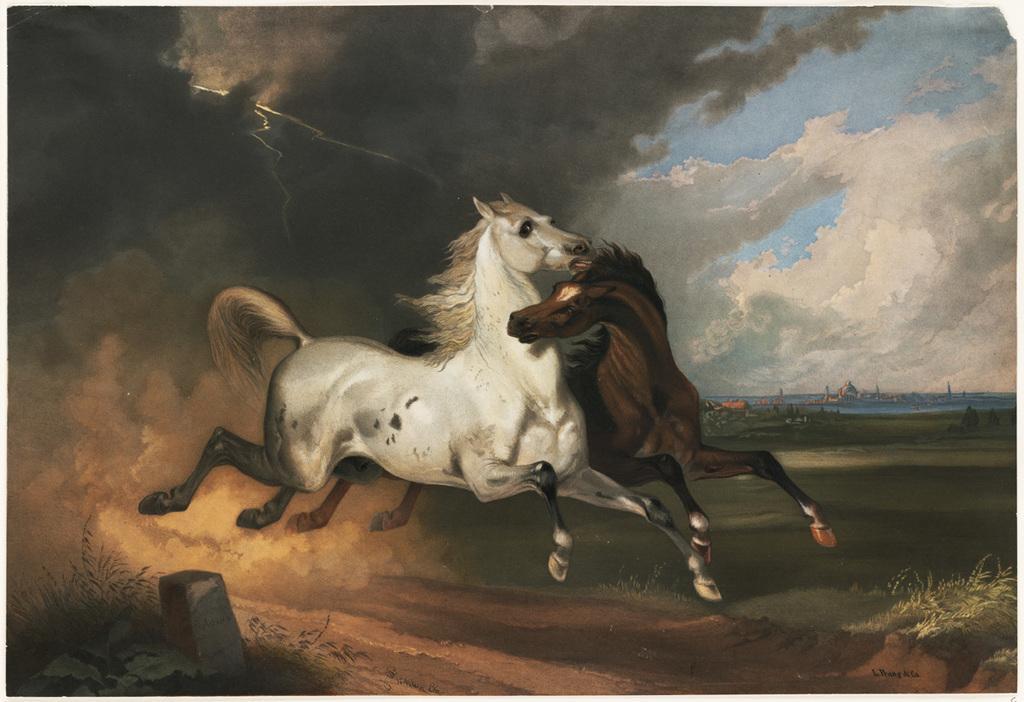How would you summarize this image in a sentence or two? In this image there is a painting of two horses, grass on the surface. At the bottom left side of the image there is a stone and a planet, behind the horses there is dust in the air. In the background there is a building, river and the sky. 